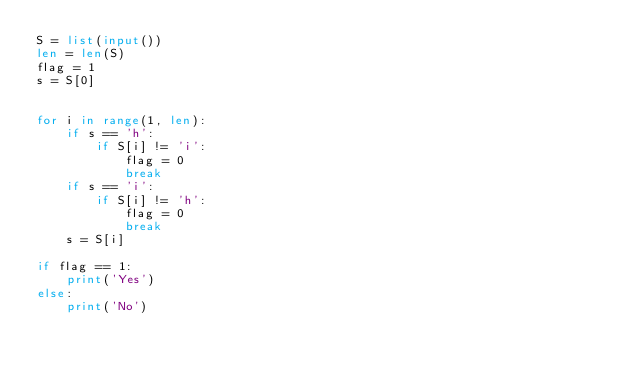Convert code to text. <code><loc_0><loc_0><loc_500><loc_500><_Python_>S = list(input())
len = len(S)
flag = 1
s = S[0]


for i in range(1, len):
    if s == 'h':
        if S[i] != 'i':
            flag = 0
            break
    if s == 'i':
        if S[i] != 'h':
            flag = 0
            break
    s = S[i]

if flag == 1:
    print('Yes')
else:
    print('No')

    </code> 